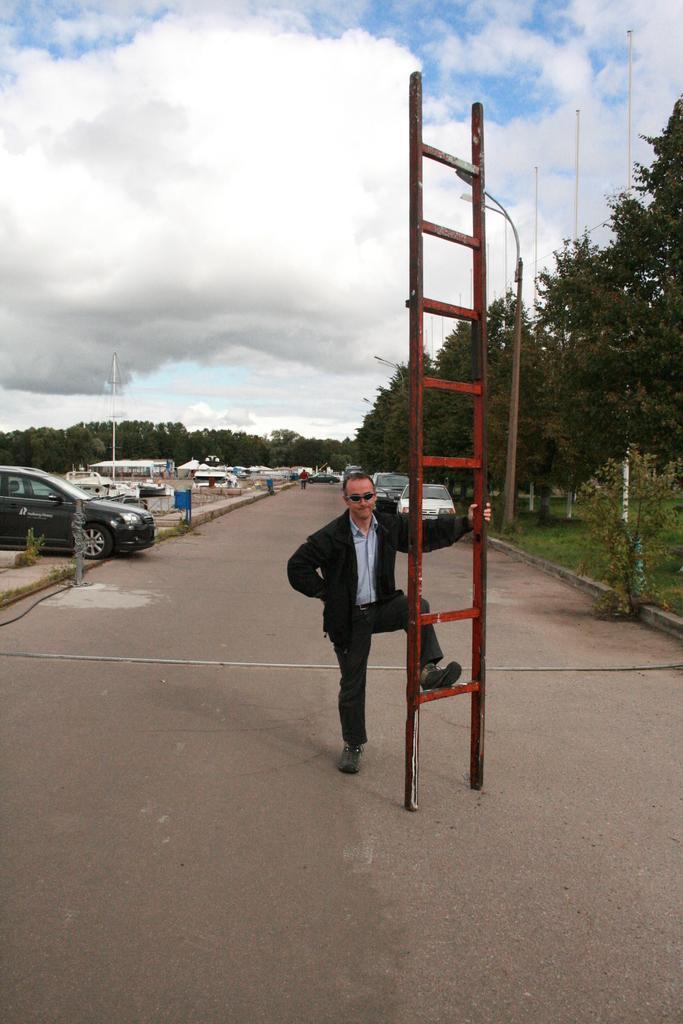Can you describe this image briefly? This is an outside view. In the middle of the image there is a man holding a ladder and standing on the ground. In the background there are many vehicles, buildings and trees. At the top of the image I can see the sky and clouds. 